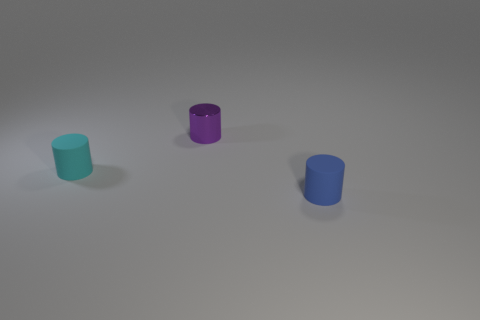Are there any other things that are the same material as the purple cylinder?
Offer a very short reply. No. The other metal thing that is the same size as the cyan thing is what color?
Provide a succinct answer. Purple. What number of large things are cylinders or metallic things?
Your response must be concise. 0. Are there the same number of cyan cylinders on the right side of the small purple metallic thing and purple metal cylinders behind the tiny blue rubber cylinder?
Give a very brief answer. No. How many red rubber cubes have the same size as the purple object?
Provide a succinct answer. 0. How many blue things are tiny rubber things or small cylinders?
Keep it short and to the point. 1. Is the number of purple things to the left of the shiny cylinder the same as the number of tiny purple things?
Your answer should be very brief. No. There is a thing in front of the cyan cylinder; what is its size?
Keep it short and to the point. Small. What number of tiny cyan objects have the same shape as the small purple shiny object?
Offer a terse response. 1. The thing that is both in front of the purple metallic cylinder and to the left of the small blue cylinder is made of what material?
Provide a succinct answer. Rubber. 